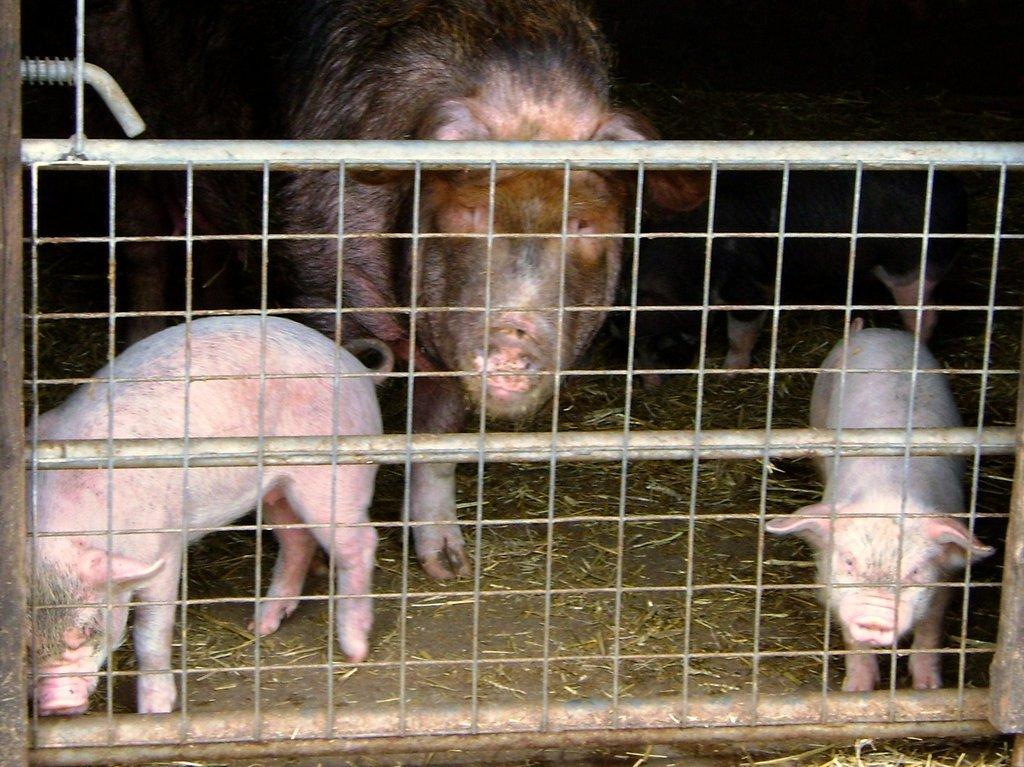Can you describe this image briefly? In this image we can see pigs and piglets in the cage. 